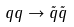<formula> <loc_0><loc_0><loc_500><loc_500>q q \rightarrow \tilde { q } \tilde { q }</formula> 